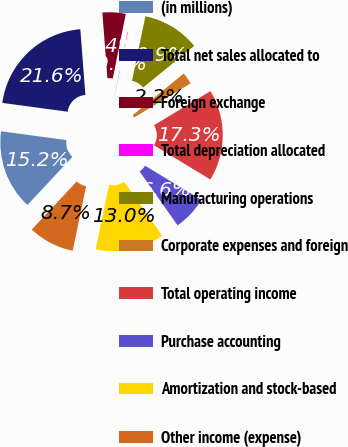Convert chart. <chart><loc_0><loc_0><loc_500><loc_500><pie_chart><fcel>(in millions)<fcel>Total net sales allocated to<fcel>Foreign exchange<fcel>Total depreciation allocated<fcel>Manufacturing operations<fcel>Corporate expenses and foreign<fcel>Total operating income<fcel>Purchase accounting<fcel>Amortization and stock-based<fcel>Other income (expense)<nl><fcel>15.17%<fcel>21.64%<fcel>4.39%<fcel>0.08%<fcel>10.86%<fcel>2.24%<fcel>17.33%<fcel>6.55%<fcel>13.02%<fcel>8.71%<nl></chart> 